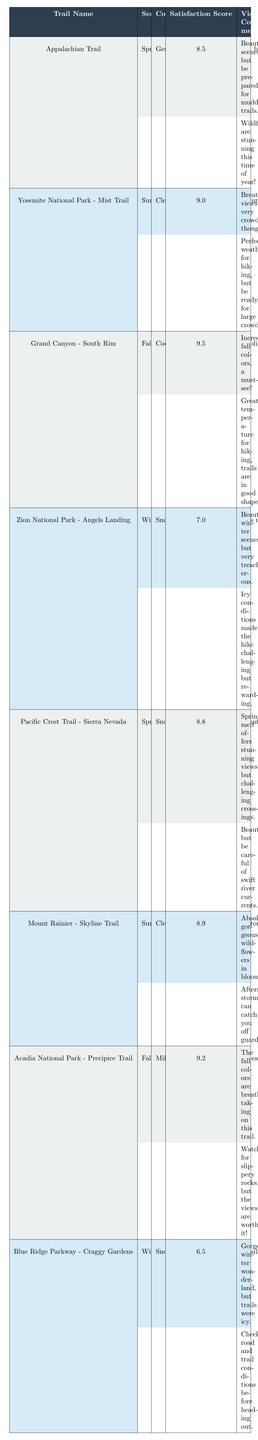What is the satisfaction score for the Pacific Crest Trail in Spring? The table shows that the satisfaction score for the Pacific Crest Trail during Spring is listed as 8.8.
Answer: 8.8 Which trail has the highest satisfaction score? By comparing the satisfaction scores listed in the table, the Grand Canyon - South Rim has the highest score of 9.5.
Answer: Grand Canyon - South Rim Is the trail condition for Zion National Park - Angels Landing in Winter described as clear? The table states that the conditions for Zion National Park - Angels Landing in Winter are snowy sections and icy trails, not clear.
Answer: No How many trails have a satisfaction score above 9.0? By reviewing the table, three trails (Yosemite National Park - Mist Trail, Grand Canyon - South Rim, and Acadia National Park - Precipice Trail) have satisfaction scores above 9.0.
Answer: 3 What is the average satisfaction score for trails in the Fall season? The satisfaction scores for Fall are: 9.5 (Grand Canyon - South Rim) and 9.2 (Acadia National Park - Precipice Trail). Adding these gives 9.5 + 9.2 = 18.7, and there are 2 trails, so the average is 18.7 / 2 = 9.35.
Answer: 9.35 Which trail has the best conditions in Summer? The Yosemite National Park - Mist Trail has conditions described as clear and popular with warm temperatures, which is generally considered the best for summer hiking among the options listed.
Answer: Yosemite National Park - Mist Trail What are the visitor comments for trails in Winter? The visitor comments for trails in Winter are: 1) "Beautiful winter scenery, but very treacherous" and "Icy conditions made the hike challenging but rewarding" for Zion National Park - Angels Landing; 2) "Gorgeous winter wonderland, but trails were icy" and "Check road and trail conditions before heading out" for Blue Ridge Parkway - Craggy Gardens.
Answer: Summarized comments: treacherous and icy conditions noted for both Does the Appalachian Trail receive higher visitor satisfaction than the Blue Ridge Parkway - Craggy Gardens? The Appalachian Trail has a satisfaction score of 8.5 while the Blue Ridge Parkway - Craggy Gardens has a score of 6.5. Thus, the Appalachian Trail does receive higher satisfaction.
Answer: Yes What is the range of satisfaction scores for the trails listed in the table? The highest satisfaction score is 9.5 (Grand Canyon - South Rim) and the lowest is 6.5 (Blue Ridge Parkway - Craggy Gardens). The range can be calculated by subtracting the lowest from the highest: 9.5 - 6.5 = 3.
Answer: 3 How do the trail conditions in Spring compare to those in Winter? In Spring, conditions are mostly wet with muddy sections and blooming wildflowers, while Winter conditions include snowy sections and icy trails. Spring conditions are generally more favorable compared to Winter's hazards.
Answer: Spring has better conditions 